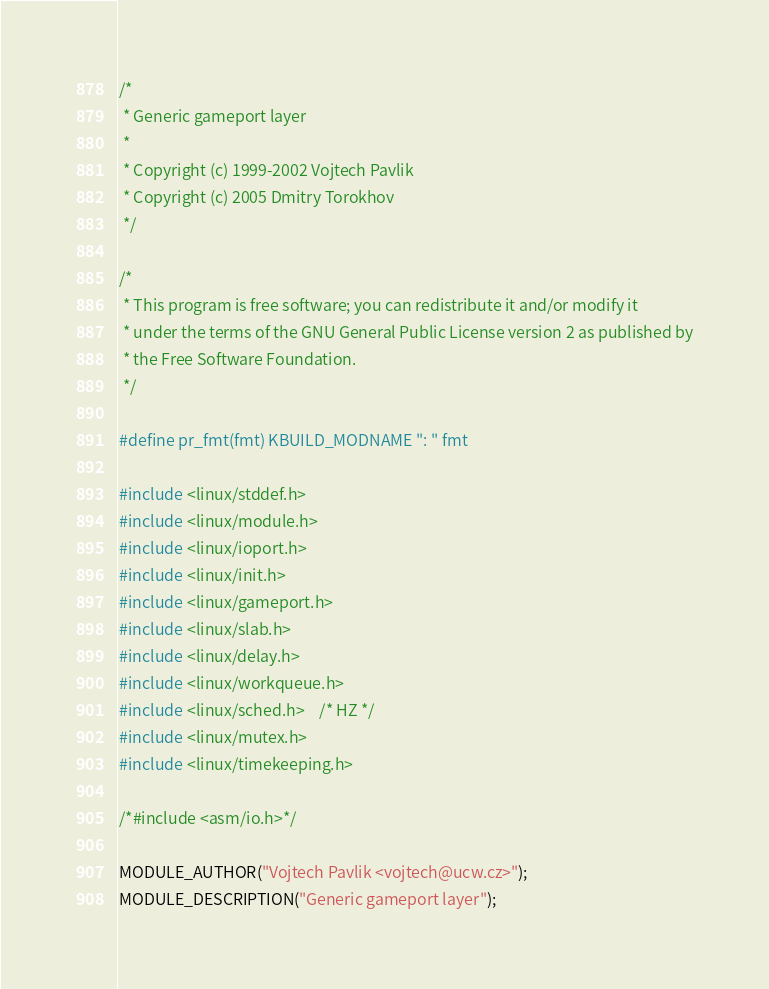Convert code to text. <code><loc_0><loc_0><loc_500><loc_500><_C_>/*
 * Generic gameport layer
 *
 * Copyright (c) 1999-2002 Vojtech Pavlik
 * Copyright (c) 2005 Dmitry Torokhov
 */

/*
 * This program is free software; you can redistribute it and/or modify it
 * under the terms of the GNU General Public License version 2 as published by
 * the Free Software Foundation.
 */

#define pr_fmt(fmt) KBUILD_MODNAME ": " fmt

#include <linux/stddef.h>
#include <linux/module.h>
#include <linux/ioport.h>
#include <linux/init.h>
#include <linux/gameport.h>
#include <linux/slab.h>
#include <linux/delay.h>
#include <linux/workqueue.h>
#include <linux/sched.h>	/* HZ */
#include <linux/mutex.h>
#include <linux/timekeeping.h>

/*#include <asm/io.h>*/

MODULE_AUTHOR("Vojtech Pavlik <vojtech@ucw.cz>");
MODULE_DESCRIPTION("Generic gameport layer");</code> 